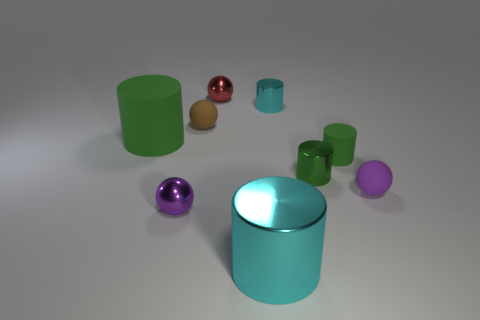Subtract all brown blocks. How many green cylinders are left? 3 Subtract all small matte cylinders. How many cylinders are left? 4 Subtract all red balls. How many balls are left? 3 Subtract 1 spheres. How many spheres are left? 3 Subtract all brown cylinders. Subtract all green blocks. How many cylinders are left? 5 Add 1 tiny rubber cubes. How many objects exist? 10 Subtract all spheres. How many objects are left? 5 Add 6 small gray metallic objects. How many small gray metallic objects exist? 6 Subtract 0 gray spheres. How many objects are left? 9 Subtract all big brown cubes. Subtract all purple matte things. How many objects are left? 8 